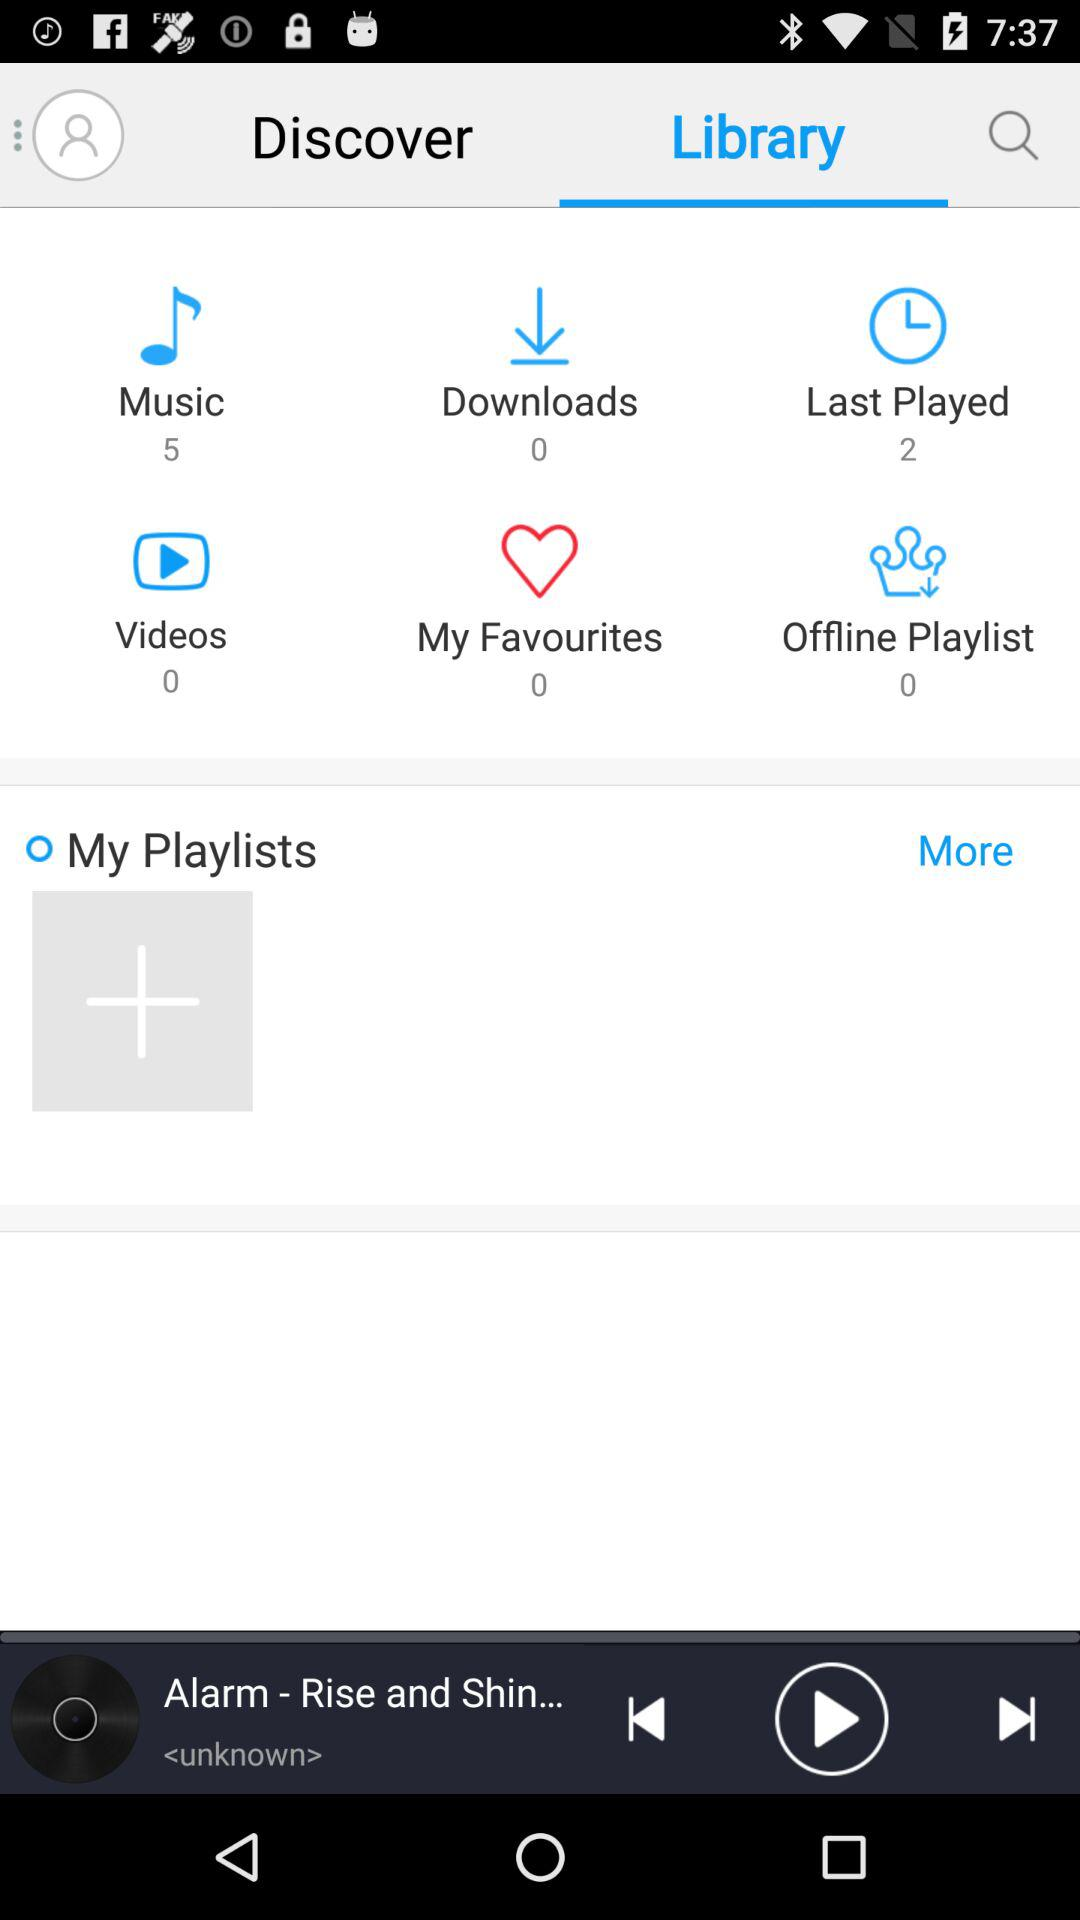Which song was last played? The last played ringtone was "Alarm - Rise and Shin...". 